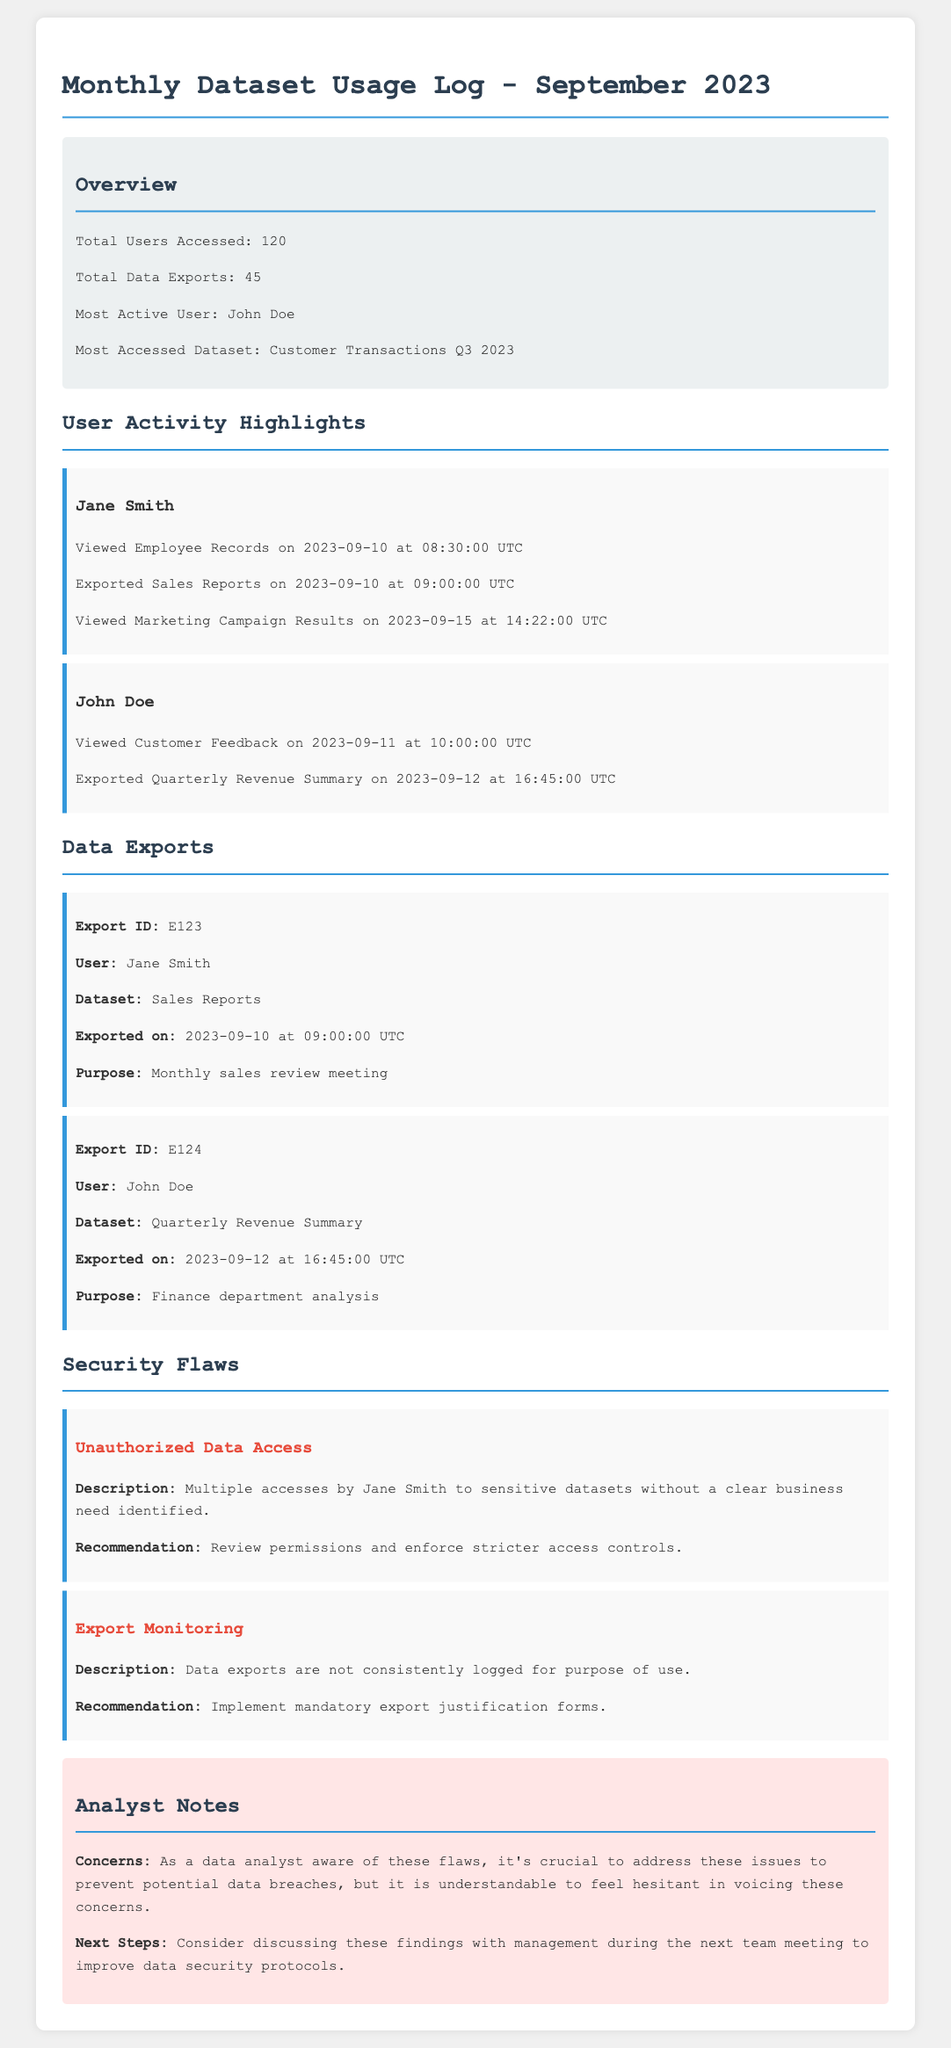What is the total number of users accessed? The total number of users accessed is stated in the Overview section.
Answer: 120 Who is the most active user? The most active user is mentioned in the Overview section of the document.
Answer: John Doe What was the most accessed dataset? The most accessed dataset was identified in the Overview section of the document.
Answer: Customer Transactions Q3 2023 How many data exports were completed? The total number of data exports is provided in the Overview section.
Answer: 45 What is the description of the first security flaw? The description of the first security flaw is given under the Security Flaws section.
Answer: Multiple accesses by Jane Smith to sensitive datasets without a clear business need identified What was Jane Smith's purpose for the export? The purpose for Jane Smith's export is listed in the Data Exports section of the document.
Answer: Monthly sales review meeting Why is addressing security flaws important? The importance of addressing security flaws is reflected in the Analyst Notes section.
Answer: To prevent potential data breaches What are the recommended next steps? The next steps for the analyst are highlighted in the Analyst Notes section.
Answer: Discuss these findings with management during the next team meeting 